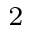<formula> <loc_0><loc_0><loc_500><loc_500>^ { 2 }</formula> 